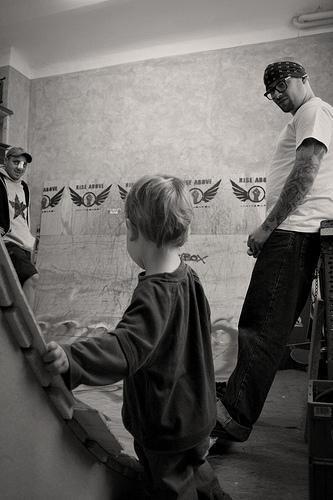How many items of clothing can you see the child wearing?
Give a very brief answer. 2. How many people are there?
Give a very brief answer. 3. How many people can you see?
Give a very brief answer. 3. 